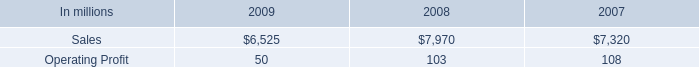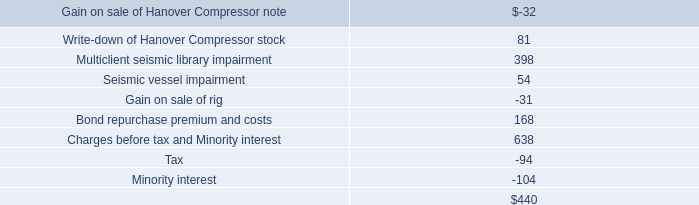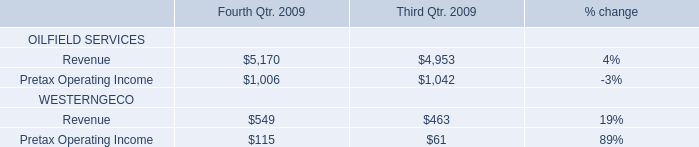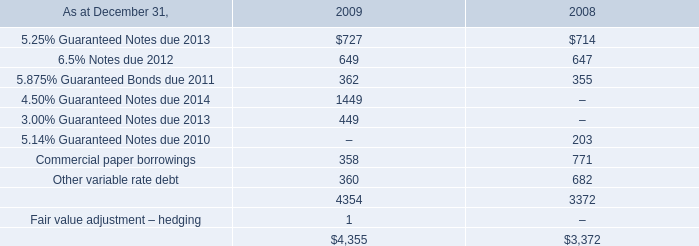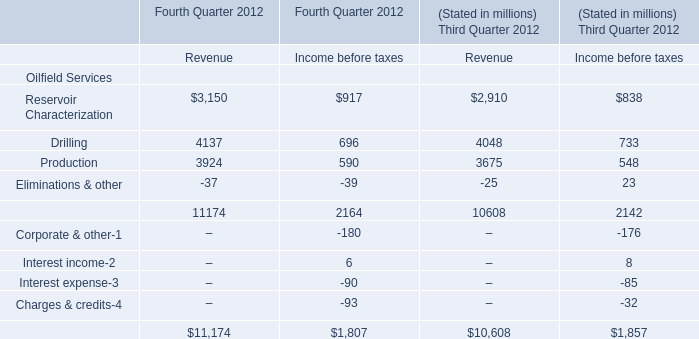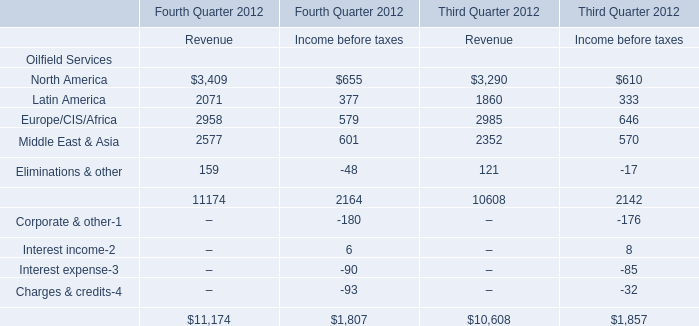What is the ratio of all Revenue that are smaller than 4000 to the sum of Revenue for Fourth Quarter 2012? 
Computations: (((3150 + 3924) - 37) / (((3150 + 3924) - 37) + 4137))
Answer: 0.62977. 